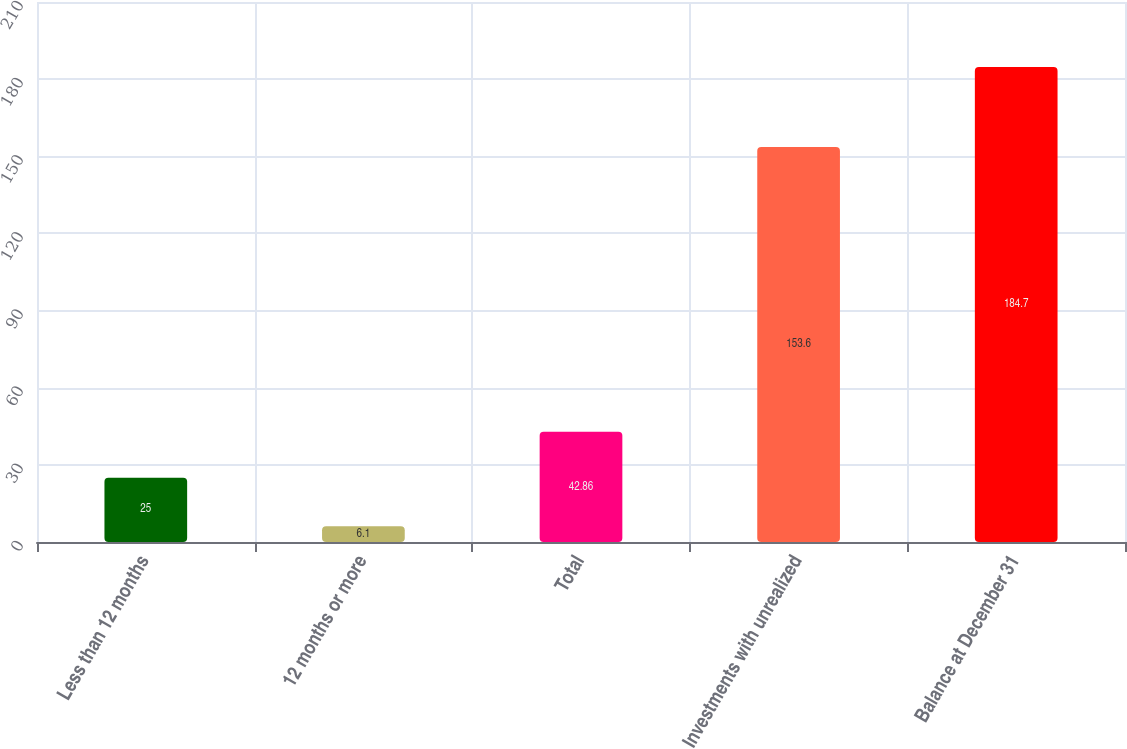<chart> <loc_0><loc_0><loc_500><loc_500><bar_chart><fcel>Less than 12 months<fcel>12 months or more<fcel>Total<fcel>Investments with unrealized<fcel>Balance at December 31<nl><fcel>25<fcel>6.1<fcel>42.86<fcel>153.6<fcel>184.7<nl></chart> 